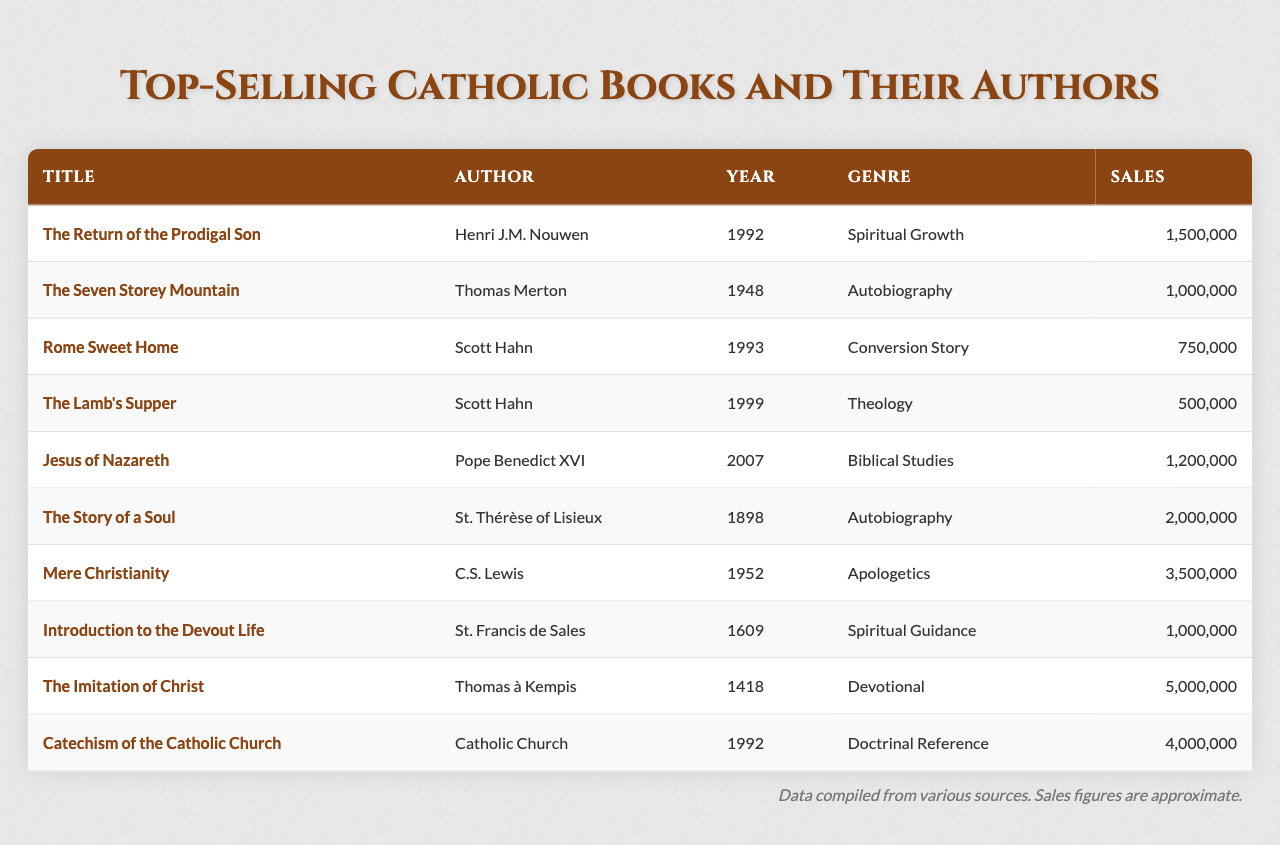What is the best-selling Catholic book according to the table? The book with the highest sales is "The Imitation of Christ" with 5,000,000 copies sold.
Answer: "The Imitation of Christ" Who is the author of "The Seven Storey Mountain"? The author of "The Seven Storey Mountain" is Thomas Merton.
Answer: Thomas Merton How many books were written by Scott Hahn in the list? There are two books written by Scott Hahn: "Rome Sweet Home" and "The Lamb's Supper".
Answer: Two What is the sales difference between "Mere Christianity" and "The Lamb's Supper"? "Mere Christianity" sold 3,500,000 copies and "The Lamb's Supper" sold 500,000 copies. The difference is 3,500,000 - 500,000 = 3,000,000.
Answer: 3,000,000 Which book was published the earliest? The earliest published book is "The Imitation of Christ," which was published in 1418.
Answer: "The Imitation of Christ" What is the total sales of all books listed in the table? The total sales are calculated by adding each book's sales: 1,500,000 + 1,000,000 + 750,000 + 500,000 + 1,200,000 + 2,000,000 + 3,500,000 + 1,000,000 + 5,000,000 + 4,000,000 = 20,000,000.
Answer: 20,000,000 Is there a book by a Pope in the list? Yes, "Jesus of Nazareth" is written by Pope Benedict XVI.
Answer: Yes How many books in the list focus on Spiritual Growth? There is one book specifically labeled as "Spiritual Growth," which is "The Return of the Prodigal Son."
Answer: One Which author has the highest total book sales when their works are combined? C.S. Lewis has the highest total book sales with "Mere Christianity." He has achieved 3,500,000 sales, while other authors have lower combined totals.
Answer: C.S. Lewis In what year was "The Story of a Soul" published? "The Story of a Soul" was published in 1898.
Answer: 1898 